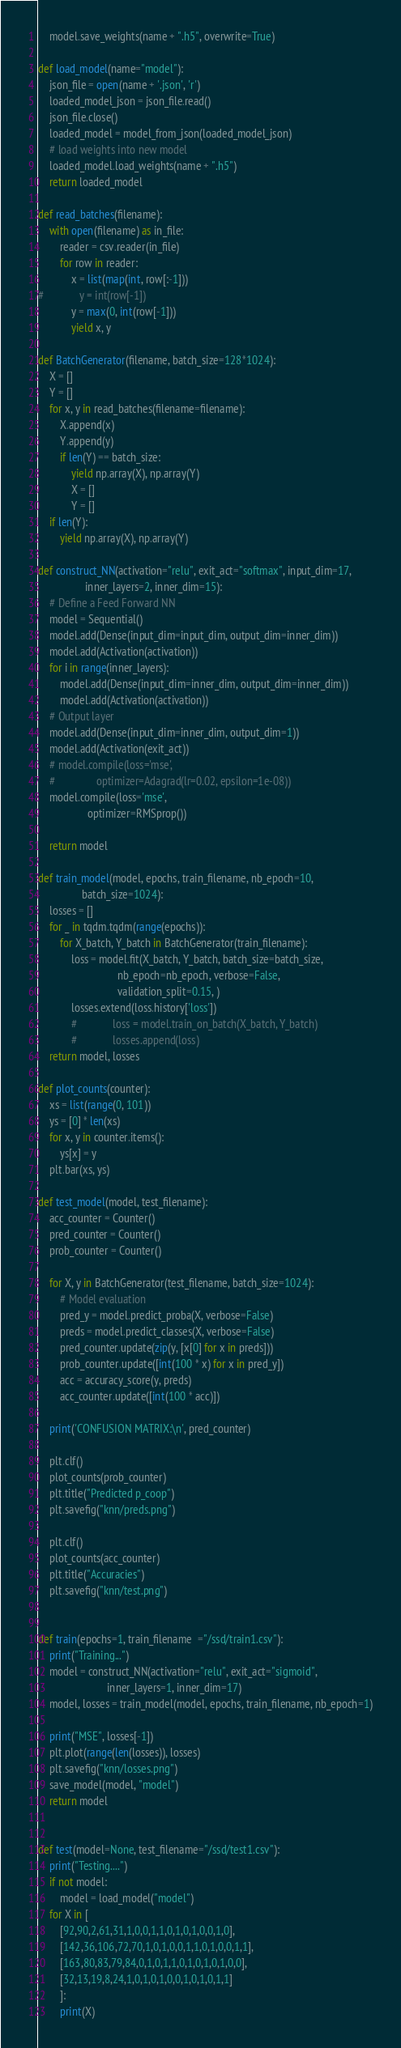<code> <loc_0><loc_0><loc_500><loc_500><_Python_>    model.save_weights(name + ".h5", overwrite=True)

def load_model(name="model"):
    json_file = open(name + '.json', 'r')
    loaded_model_json = json_file.read()
    json_file.close()
    loaded_model = model_from_json(loaded_model_json)
    # load weights into new model
    loaded_model.load_weights(name + ".h5")
    return loaded_model

def read_batches(filename):
    with open(filename) as in_file:
        reader = csv.reader(in_file)
        for row in reader:
            x = list(map(int, row[:-1]))
#             y = int(row[-1])
            y = max(0, int(row[-1]))
            yield x, y

def BatchGenerator(filename, batch_size=128*1024):
    X = []
    Y = []
    for x, y in read_batches(filename=filename):
        X.append(x)
        Y.append(y)
        if len(Y) == batch_size:
            yield np.array(X), np.array(Y)
            X = []
            Y = []
    if len(Y):
        yield np.array(X), np.array(Y)

def construct_NN(activation="relu", exit_act="softmax", input_dim=17,
                 inner_layers=2, inner_dim=15):
    # Define a Feed Forward NN
    model = Sequential()
    model.add(Dense(input_dim=input_dim, output_dim=inner_dim))
    model.add(Activation(activation))
    for i in range(inner_layers):
        model.add(Dense(input_dim=inner_dim, output_dim=inner_dim))
        model.add(Activation(activation))
    # Output layer
    model.add(Dense(input_dim=inner_dim, output_dim=1))
    model.add(Activation(exit_act))
    # model.compile(loss='mse',
    #               optimizer=Adagrad(lr=0.02, epsilon=1e-08))
    model.compile(loss='mse',
                  optimizer=RMSprop())

    return model

def train_model(model, epochs, train_filename, nb_epoch=10,
                batch_size=1024):
    losses = []
    for _ in tqdm.tqdm(range(epochs)):
        for X_batch, Y_batch in BatchGenerator(train_filename):
            loss = model.fit(X_batch, Y_batch, batch_size=batch_size,
                             nb_epoch=nb_epoch, verbose=False,
                             validation_split=0.15, )
            losses.extend(loss.history['loss'])
            #             loss = model.train_on_batch(X_batch, Y_batch)
            #             losses.append(loss)
    return model, losses

def plot_counts(counter):
    xs = list(range(0, 101))
    ys = [0] * len(xs)
    for x, y in counter.items():
        ys[x] = y
    plt.bar(xs, ys)

def test_model(model, test_filename):
    acc_counter = Counter()
    pred_counter = Counter()
    prob_counter = Counter()

    for X, y in BatchGenerator(test_filename, batch_size=1024):
        # Model evaluation
        pred_y = model.predict_proba(X, verbose=False)
        preds = model.predict_classes(X, verbose=False)
        pred_counter.update(zip(y, [x[0] for x in preds]))
        prob_counter.update([int(100 * x) for x in pred_y])
        acc = accuracy_score(y, preds)
        acc_counter.update([int(100 * acc)])

    print('CONFUSION MATRIX:\n', pred_counter)

    plt.clf()
    plot_counts(prob_counter)
    plt.title("Predicted p_coop")
    plt.savefig("knn/preds.png")

    plt.clf()
    plot_counts(acc_counter)
    plt.title("Accuracies")
    plt.savefig("knn/test.png")


def train(epochs=1, train_filename  ="/ssd/train1.csv"):
    print("Training...")
    model = construct_NN(activation="relu", exit_act="sigmoid",
                         inner_layers=1, inner_dim=17)
    model, losses = train_model(model, epochs, train_filename, nb_epoch=1)

    print("MSE", losses[-1])
    plt.plot(range(len(losses)), losses)
    plt.savefig("knn/losses.png")
    save_model(model, "model")
    return model


def test(model=None, test_filename="/ssd/test1.csv"):
    print("Testing....")
    if not model:
        model = load_model("model")
    for X in [
        [92,90,2,61,31,1,0,0,1,1,0,1,0,1,0,0,1,0],
        [142,36,106,72,70,1,0,1,0,0,1,1,0,1,0,0,1,1],
        [163,80,83,79,84,0,1,0,1,1,0,1,0,1,0,1,0,0],
        [32,13,19,8,24,1,0,1,0,1,0,0,1,0,1,0,1,1]
        ]:
        print(X)</code> 